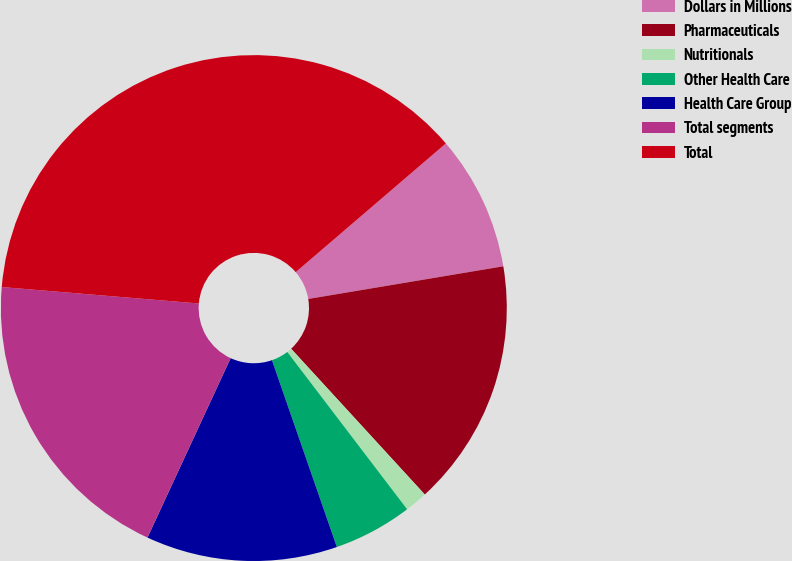Convert chart to OTSL. <chart><loc_0><loc_0><loc_500><loc_500><pie_chart><fcel>Dollars in Millions<fcel>Pharmaceuticals<fcel>Nutritionals<fcel>Other Health Care<fcel>Health Care Group<fcel>Total segments<fcel>Total<nl><fcel>8.64%<fcel>15.83%<fcel>1.45%<fcel>5.04%<fcel>12.23%<fcel>19.42%<fcel>37.4%<nl></chart> 